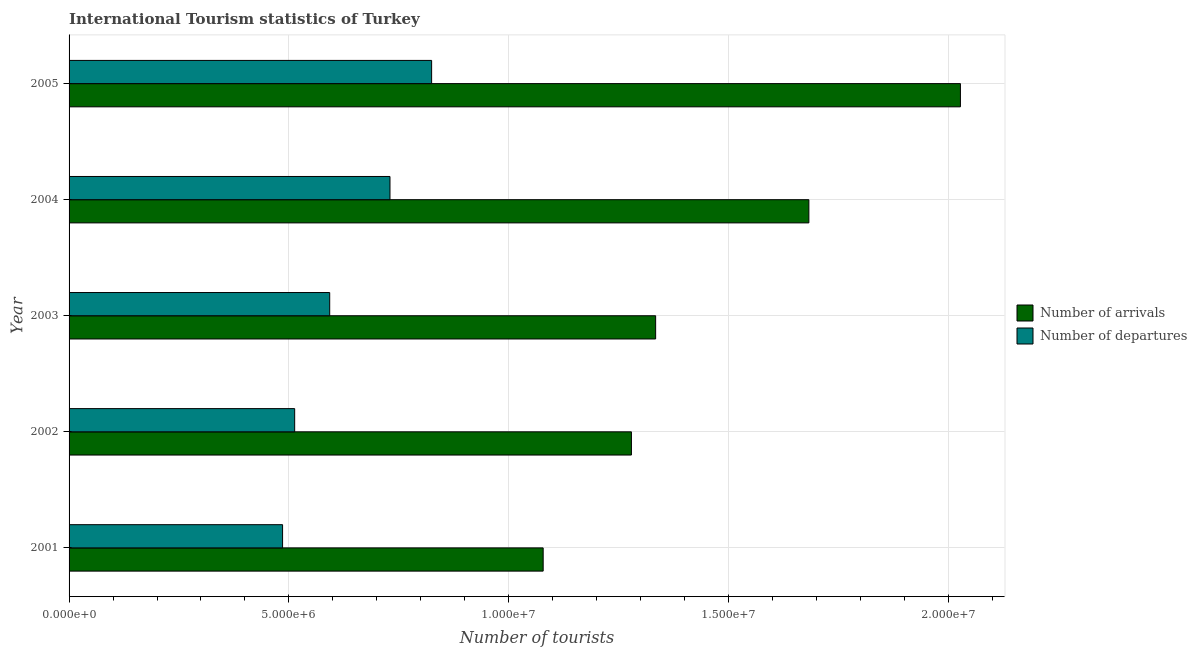How many groups of bars are there?
Give a very brief answer. 5. How many bars are there on the 2nd tick from the top?
Offer a terse response. 2. What is the label of the 2nd group of bars from the top?
Offer a terse response. 2004. In how many cases, is the number of bars for a given year not equal to the number of legend labels?
Make the answer very short. 0. What is the number of tourist arrivals in 2002?
Your answer should be very brief. 1.28e+07. Across all years, what is the maximum number of tourist departures?
Make the answer very short. 8.25e+06. Across all years, what is the minimum number of tourist departures?
Ensure brevity in your answer.  4.86e+06. What is the total number of tourist arrivals in the graph?
Offer a terse response. 7.40e+07. What is the difference between the number of tourist arrivals in 2003 and that in 2004?
Your response must be concise. -3.48e+06. What is the difference between the number of tourist arrivals in 2002 and the number of tourist departures in 2004?
Your answer should be compact. 5.49e+06. What is the average number of tourist arrivals per year?
Provide a short and direct response. 1.48e+07. In the year 2002, what is the difference between the number of tourist arrivals and number of tourist departures?
Provide a succinct answer. 7.66e+06. What is the ratio of the number of tourist arrivals in 2001 to that in 2002?
Your answer should be very brief. 0.84. Is the difference between the number of tourist departures in 2002 and 2004 greater than the difference between the number of tourist arrivals in 2002 and 2004?
Offer a terse response. Yes. What is the difference between the highest and the second highest number of tourist arrivals?
Your response must be concise. 3.45e+06. What is the difference between the highest and the lowest number of tourist departures?
Keep it short and to the point. 3.39e+06. Is the sum of the number of tourist arrivals in 2001 and 2004 greater than the maximum number of tourist departures across all years?
Make the answer very short. Yes. What does the 1st bar from the top in 2005 represents?
Make the answer very short. Number of departures. What does the 2nd bar from the bottom in 2005 represents?
Your answer should be very brief. Number of departures. Are all the bars in the graph horizontal?
Keep it short and to the point. Yes. What is the difference between two consecutive major ticks on the X-axis?
Offer a terse response. 5.00e+06. Are the values on the major ticks of X-axis written in scientific E-notation?
Offer a very short reply. Yes. Does the graph contain grids?
Your answer should be compact. Yes. How many legend labels are there?
Provide a succinct answer. 2. How are the legend labels stacked?
Offer a very short reply. Vertical. What is the title of the graph?
Offer a terse response. International Tourism statistics of Turkey. What is the label or title of the X-axis?
Provide a succinct answer. Number of tourists. What is the Number of tourists in Number of arrivals in 2001?
Make the answer very short. 1.08e+07. What is the Number of tourists in Number of departures in 2001?
Give a very brief answer. 4.86e+06. What is the Number of tourists of Number of arrivals in 2002?
Make the answer very short. 1.28e+07. What is the Number of tourists of Number of departures in 2002?
Keep it short and to the point. 5.13e+06. What is the Number of tourists of Number of arrivals in 2003?
Your answer should be very brief. 1.33e+07. What is the Number of tourists in Number of departures in 2003?
Keep it short and to the point. 5.93e+06. What is the Number of tourists in Number of arrivals in 2004?
Ensure brevity in your answer.  1.68e+07. What is the Number of tourists of Number of departures in 2004?
Provide a succinct answer. 7.30e+06. What is the Number of tourists in Number of arrivals in 2005?
Provide a short and direct response. 2.03e+07. What is the Number of tourists of Number of departures in 2005?
Your answer should be compact. 8.25e+06. Across all years, what is the maximum Number of tourists in Number of arrivals?
Provide a succinct answer. 2.03e+07. Across all years, what is the maximum Number of tourists in Number of departures?
Ensure brevity in your answer.  8.25e+06. Across all years, what is the minimum Number of tourists of Number of arrivals?
Ensure brevity in your answer.  1.08e+07. Across all years, what is the minimum Number of tourists in Number of departures?
Offer a terse response. 4.86e+06. What is the total Number of tourists in Number of arrivals in the graph?
Make the answer very short. 7.40e+07. What is the total Number of tourists in Number of departures in the graph?
Your answer should be compact. 3.15e+07. What is the difference between the Number of tourists of Number of arrivals in 2001 and that in 2002?
Provide a succinct answer. -2.01e+06. What is the difference between the Number of tourists of Number of departures in 2001 and that in 2002?
Offer a very short reply. -2.75e+05. What is the difference between the Number of tourists of Number of arrivals in 2001 and that in 2003?
Provide a succinct answer. -2.56e+06. What is the difference between the Number of tourists in Number of departures in 2001 and that in 2003?
Provide a short and direct response. -1.07e+06. What is the difference between the Number of tourists of Number of arrivals in 2001 and that in 2004?
Give a very brief answer. -6.04e+06. What is the difference between the Number of tourists of Number of departures in 2001 and that in 2004?
Provide a succinct answer. -2.44e+06. What is the difference between the Number of tourists of Number of arrivals in 2001 and that in 2005?
Make the answer very short. -9.49e+06. What is the difference between the Number of tourists of Number of departures in 2001 and that in 2005?
Offer a very short reply. -3.39e+06. What is the difference between the Number of tourists of Number of arrivals in 2002 and that in 2003?
Your response must be concise. -5.51e+05. What is the difference between the Number of tourists of Number of departures in 2002 and that in 2003?
Keep it short and to the point. -7.97e+05. What is the difference between the Number of tourists of Number of arrivals in 2002 and that in 2004?
Your answer should be compact. -4.04e+06. What is the difference between the Number of tourists in Number of departures in 2002 and that in 2004?
Your answer should be compact. -2.17e+06. What is the difference between the Number of tourists in Number of arrivals in 2002 and that in 2005?
Provide a short and direct response. -7.48e+06. What is the difference between the Number of tourists of Number of departures in 2002 and that in 2005?
Your answer should be very brief. -3.12e+06. What is the difference between the Number of tourists of Number of arrivals in 2003 and that in 2004?
Your answer should be compact. -3.48e+06. What is the difference between the Number of tourists in Number of departures in 2003 and that in 2004?
Provide a succinct answer. -1.37e+06. What is the difference between the Number of tourists of Number of arrivals in 2003 and that in 2005?
Offer a very short reply. -6.93e+06. What is the difference between the Number of tourists of Number of departures in 2003 and that in 2005?
Offer a terse response. -2.32e+06. What is the difference between the Number of tourists in Number of arrivals in 2004 and that in 2005?
Keep it short and to the point. -3.45e+06. What is the difference between the Number of tourists of Number of departures in 2004 and that in 2005?
Give a very brief answer. -9.47e+05. What is the difference between the Number of tourists in Number of arrivals in 2001 and the Number of tourists in Number of departures in 2002?
Your answer should be very brief. 5.65e+06. What is the difference between the Number of tourists in Number of arrivals in 2001 and the Number of tourists in Number of departures in 2003?
Give a very brief answer. 4.86e+06. What is the difference between the Number of tourists in Number of arrivals in 2001 and the Number of tourists in Number of departures in 2004?
Ensure brevity in your answer.  3.48e+06. What is the difference between the Number of tourists in Number of arrivals in 2001 and the Number of tourists in Number of departures in 2005?
Make the answer very short. 2.54e+06. What is the difference between the Number of tourists in Number of arrivals in 2002 and the Number of tourists in Number of departures in 2003?
Your answer should be compact. 6.86e+06. What is the difference between the Number of tourists of Number of arrivals in 2002 and the Number of tourists of Number of departures in 2004?
Give a very brief answer. 5.49e+06. What is the difference between the Number of tourists in Number of arrivals in 2002 and the Number of tourists in Number of departures in 2005?
Keep it short and to the point. 4.54e+06. What is the difference between the Number of tourists in Number of arrivals in 2003 and the Number of tourists in Number of departures in 2004?
Offer a very short reply. 6.04e+06. What is the difference between the Number of tourists in Number of arrivals in 2003 and the Number of tourists in Number of departures in 2005?
Your answer should be compact. 5.10e+06. What is the difference between the Number of tourists in Number of arrivals in 2004 and the Number of tourists in Number of departures in 2005?
Provide a short and direct response. 8.58e+06. What is the average Number of tourists in Number of arrivals per year?
Make the answer very short. 1.48e+07. What is the average Number of tourists of Number of departures per year?
Ensure brevity in your answer.  6.29e+06. In the year 2001, what is the difference between the Number of tourists of Number of arrivals and Number of tourists of Number of departures?
Provide a succinct answer. 5.93e+06. In the year 2002, what is the difference between the Number of tourists in Number of arrivals and Number of tourists in Number of departures?
Your answer should be compact. 7.66e+06. In the year 2003, what is the difference between the Number of tourists in Number of arrivals and Number of tourists in Number of departures?
Give a very brief answer. 7.41e+06. In the year 2004, what is the difference between the Number of tourists in Number of arrivals and Number of tourists in Number of departures?
Provide a short and direct response. 9.53e+06. In the year 2005, what is the difference between the Number of tourists of Number of arrivals and Number of tourists of Number of departures?
Ensure brevity in your answer.  1.20e+07. What is the ratio of the Number of tourists of Number of arrivals in 2001 to that in 2002?
Your response must be concise. 0.84. What is the ratio of the Number of tourists in Number of departures in 2001 to that in 2002?
Your answer should be compact. 0.95. What is the ratio of the Number of tourists in Number of arrivals in 2001 to that in 2003?
Keep it short and to the point. 0.81. What is the ratio of the Number of tourists of Number of departures in 2001 to that in 2003?
Your answer should be very brief. 0.82. What is the ratio of the Number of tourists in Number of arrivals in 2001 to that in 2004?
Keep it short and to the point. 0.64. What is the ratio of the Number of tourists of Number of departures in 2001 to that in 2004?
Ensure brevity in your answer.  0.67. What is the ratio of the Number of tourists of Number of arrivals in 2001 to that in 2005?
Provide a short and direct response. 0.53. What is the ratio of the Number of tourists in Number of departures in 2001 to that in 2005?
Make the answer very short. 0.59. What is the ratio of the Number of tourists in Number of arrivals in 2002 to that in 2003?
Provide a short and direct response. 0.96. What is the ratio of the Number of tourists of Number of departures in 2002 to that in 2003?
Provide a short and direct response. 0.87. What is the ratio of the Number of tourists in Number of arrivals in 2002 to that in 2004?
Your answer should be compact. 0.76. What is the ratio of the Number of tourists in Number of departures in 2002 to that in 2004?
Ensure brevity in your answer.  0.7. What is the ratio of the Number of tourists of Number of arrivals in 2002 to that in 2005?
Provide a short and direct response. 0.63. What is the ratio of the Number of tourists in Number of departures in 2002 to that in 2005?
Provide a short and direct response. 0.62. What is the ratio of the Number of tourists in Number of arrivals in 2003 to that in 2004?
Offer a terse response. 0.79. What is the ratio of the Number of tourists of Number of departures in 2003 to that in 2004?
Offer a terse response. 0.81. What is the ratio of the Number of tourists in Number of arrivals in 2003 to that in 2005?
Offer a very short reply. 0.66. What is the ratio of the Number of tourists of Number of departures in 2003 to that in 2005?
Your answer should be very brief. 0.72. What is the ratio of the Number of tourists of Number of arrivals in 2004 to that in 2005?
Provide a succinct answer. 0.83. What is the ratio of the Number of tourists in Number of departures in 2004 to that in 2005?
Ensure brevity in your answer.  0.89. What is the difference between the highest and the second highest Number of tourists in Number of arrivals?
Offer a terse response. 3.45e+06. What is the difference between the highest and the second highest Number of tourists of Number of departures?
Provide a short and direct response. 9.47e+05. What is the difference between the highest and the lowest Number of tourists in Number of arrivals?
Your response must be concise. 9.49e+06. What is the difference between the highest and the lowest Number of tourists in Number of departures?
Give a very brief answer. 3.39e+06. 